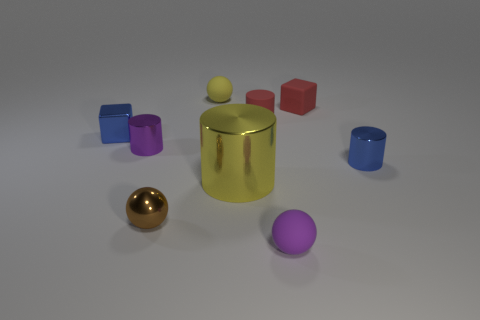What shape is the small purple object to the right of the large yellow shiny thing?
Ensure brevity in your answer.  Sphere. Is the color of the block that is behind the small red rubber cylinder the same as the tiny metal object right of the small purple rubber ball?
Your answer should be very brief. No. What number of metallic objects are both in front of the big yellow metal cylinder and to the right of the large yellow cylinder?
Offer a terse response. 0. There is a yellow thing that is the same material as the tiny purple cylinder; what size is it?
Your response must be concise. Large. The brown ball has what size?
Ensure brevity in your answer.  Small. What is the material of the tiny blue cylinder?
Keep it short and to the point. Metal. Does the block that is on the left side of the brown ball have the same size as the tiny yellow sphere?
Provide a short and direct response. Yes. How many things are either metal balls or small red matte cubes?
Ensure brevity in your answer.  2. There is a thing that is the same color as the metallic block; what shape is it?
Provide a succinct answer. Cylinder. What is the size of the matte object that is both in front of the small red block and behind the small brown ball?
Provide a short and direct response. Small. 